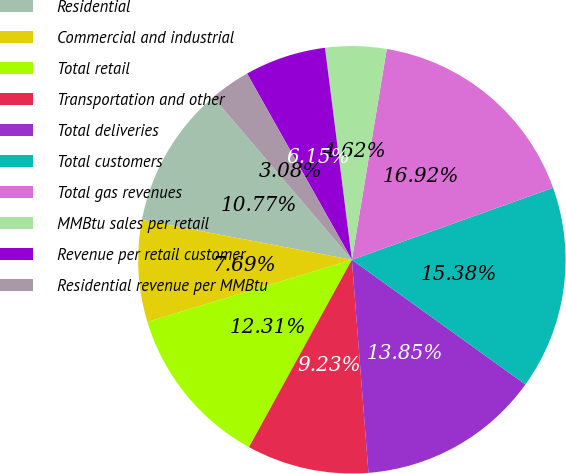Convert chart. <chart><loc_0><loc_0><loc_500><loc_500><pie_chart><fcel>Residential<fcel>Commercial and industrial<fcel>Total retail<fcel>Transportation and other<fcel>Total deliveries<fcel>Total customers<fcel>Total gas revenues<fcel>MMBtu sales per retail<fcel>Revenue per retail customer<fcel>Residential revenue per MMBtu<nl><fcel>10.77%<fcel>7.69%<fcel>12.31%<fcel>9.23%<fcel>13.85%<fcel>15.38%<fcel>16.92%<fcel>4.62%<fcel>6.15%<fcel>3.08%<nl></chart> 